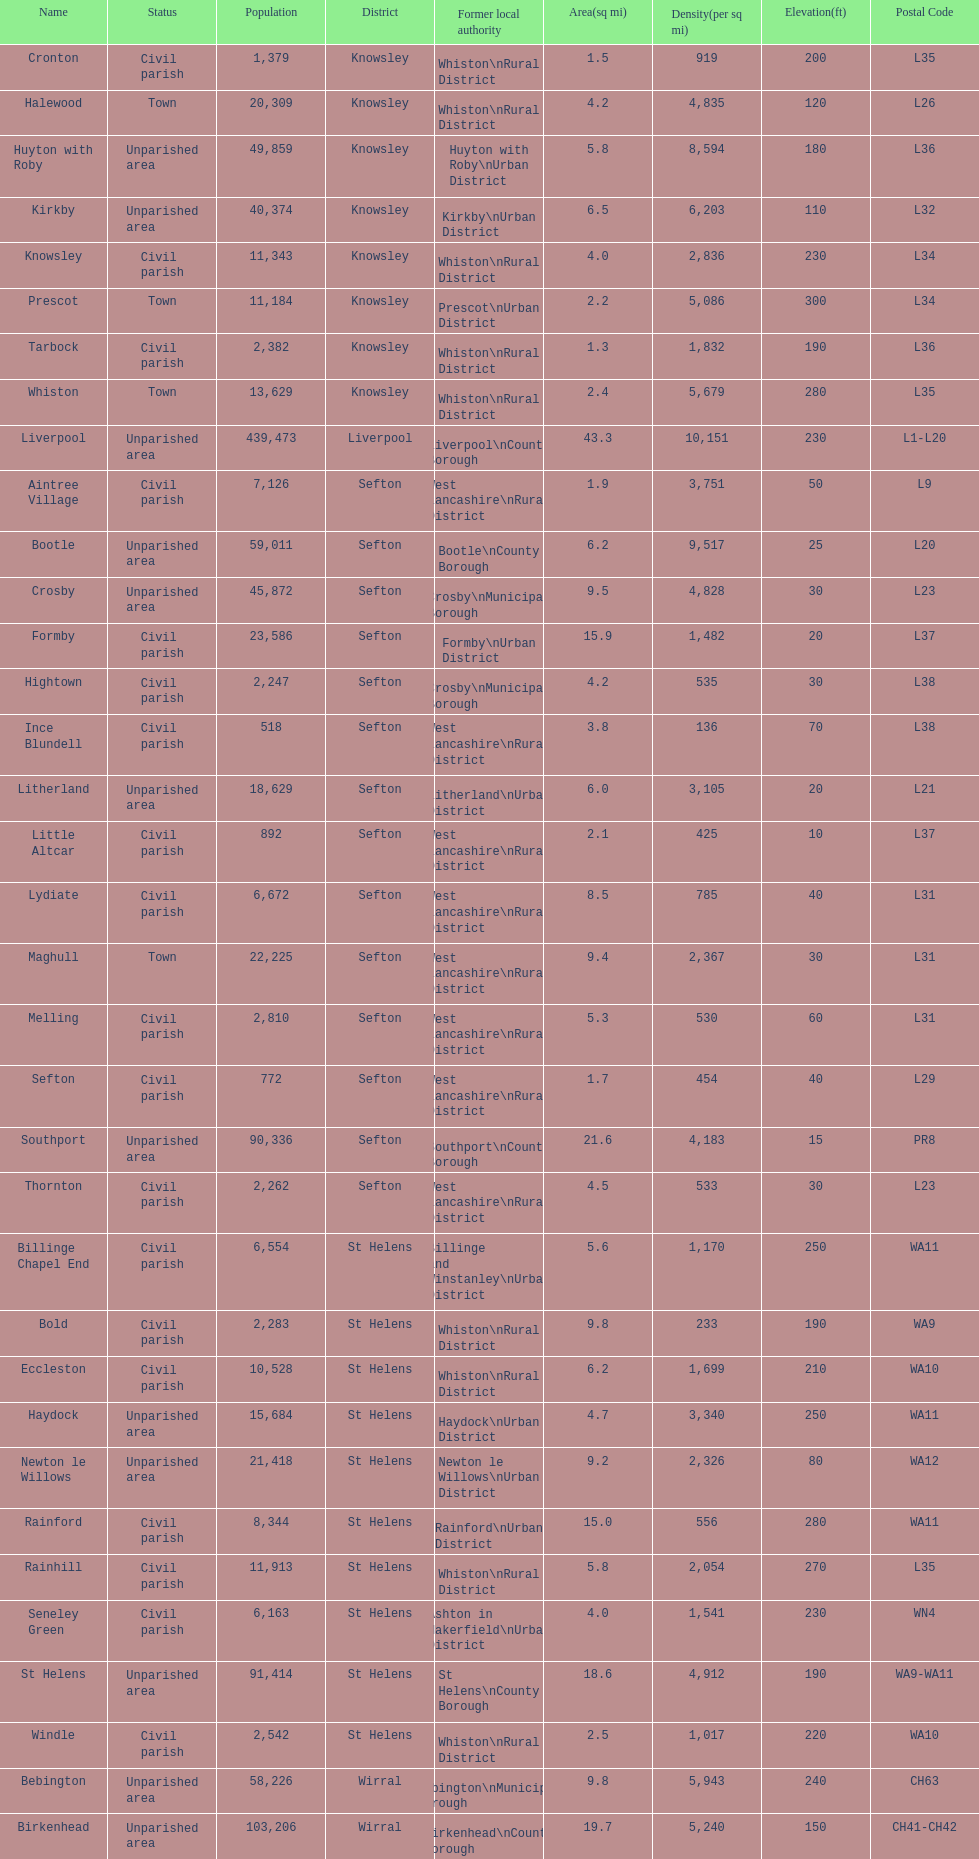Which is a civil parish, aintree village or maghull? Aintree Village. 